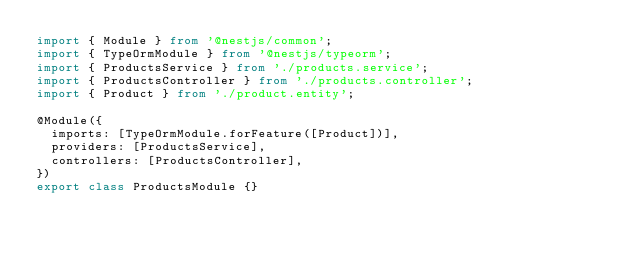<code> <loc_0><loc_0><loc_500><loc_500><_TypeScript_>import { Module } from '@nestjs/common';
import { TypeOrmModule } from '@nestjs/typeorm';
import { ProductsService } from './products.service';
import { ProductsController } from './products.controller';
import { Product } from './product.entity';

@Module({
  imports: [TypeOrmModule.forFeature([Product])],
  providers: [ProductsService],
  controllers: [ProductsController],
})
export class ProductsModule {}
</code> 